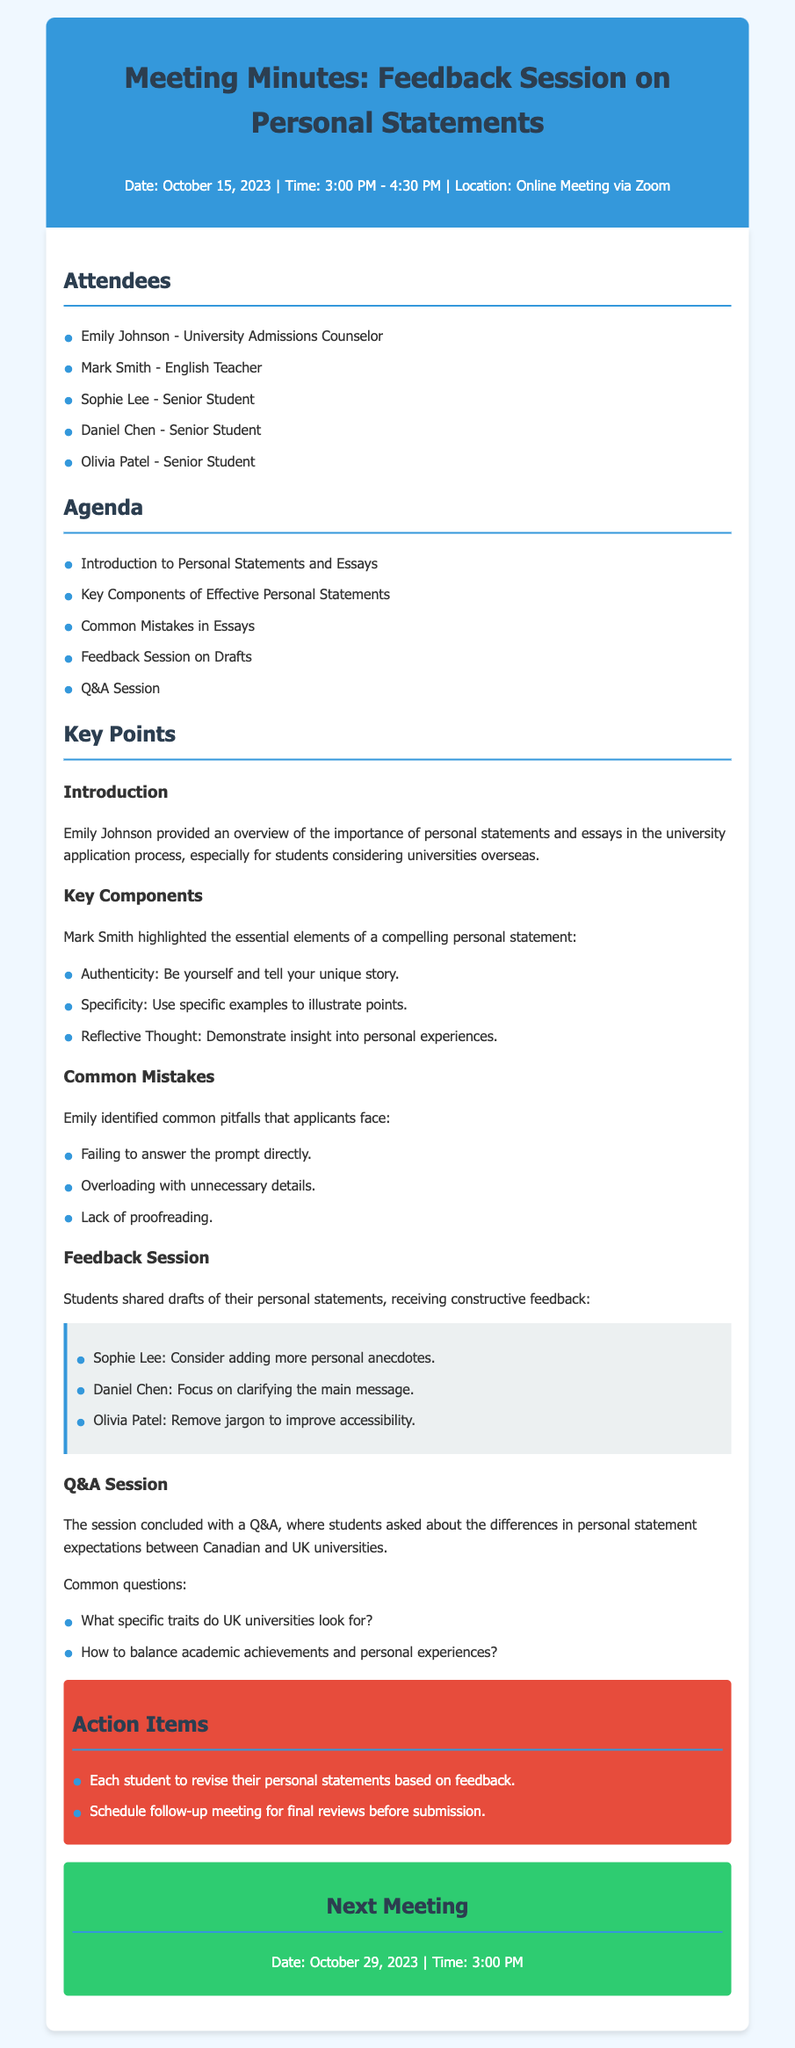what is the date of the meeting? The date of the meeting is mentioned at the beginning of the document as October 15, 2023.
Answer: October 15, 2023 who facilitated the introduction to personal statements and essays? Emily Johnson is noted as providing the overview on the importance of personal statements and essays.
Answer: Emily Johnson what essential element involves telling your unique story? The document lists authenticity as an essential component of a compelling personal statement.
Answer: Authenticity what common mistake relates to unnecessary details? Failing to overload with unnecessary details is noted as a common mistake applicants face.
Answer: Overloading with unnecessary details how many senior students attended the session? The list of attendees includes three senior students.
Answer: Three what was a feedback suggestion for Sophie Lee's draft? The feedback provided suggested that Sophie consider adding more personal anecdotes.
Answer: Adding more personal anecdotes when is the next meeting scheduled? The date for the next meeting is specified toward the end of the document as October 29, 2023.
Answer: October 29, 2023 what two traits did students ask about in the Q&A session? Students asked about specific traits and balancing academic achievements and personal experiences.
Answer: Specific traits, balancing academic achievements what is the main purpose of these meeting minutes? The document captures the feedback session on personal statements and essays for university applications.
Answer: Feedback session on personal statements and essays 